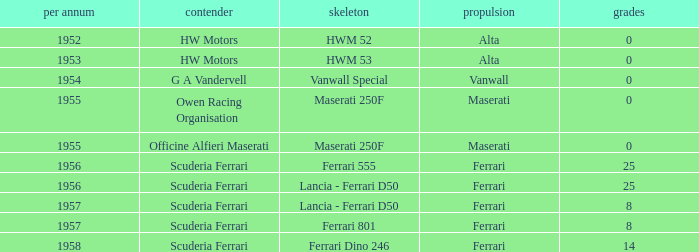What is the most points when Maserati made the engine, and a Entrant of owen racing organisation? 0.0. 